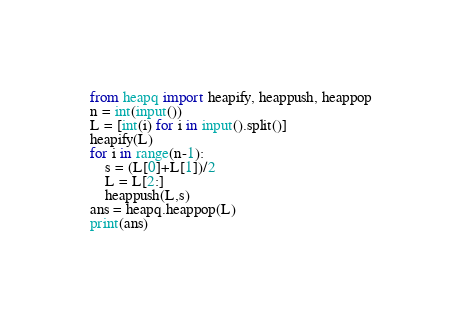<code> <loc_0><loc_0><loc_500><loc_500><_Python_>from heapq import heapify, heappush, heappop
n = int(input())
L = [int(i) for i in input().split()]
heapify(L)
for i in range(n-1):
    s = (L[0]+L[1])/2
    L = L[2:] 
    heappush(L,s)
ans = heapq.heappop(L)
print(ans)</code> 